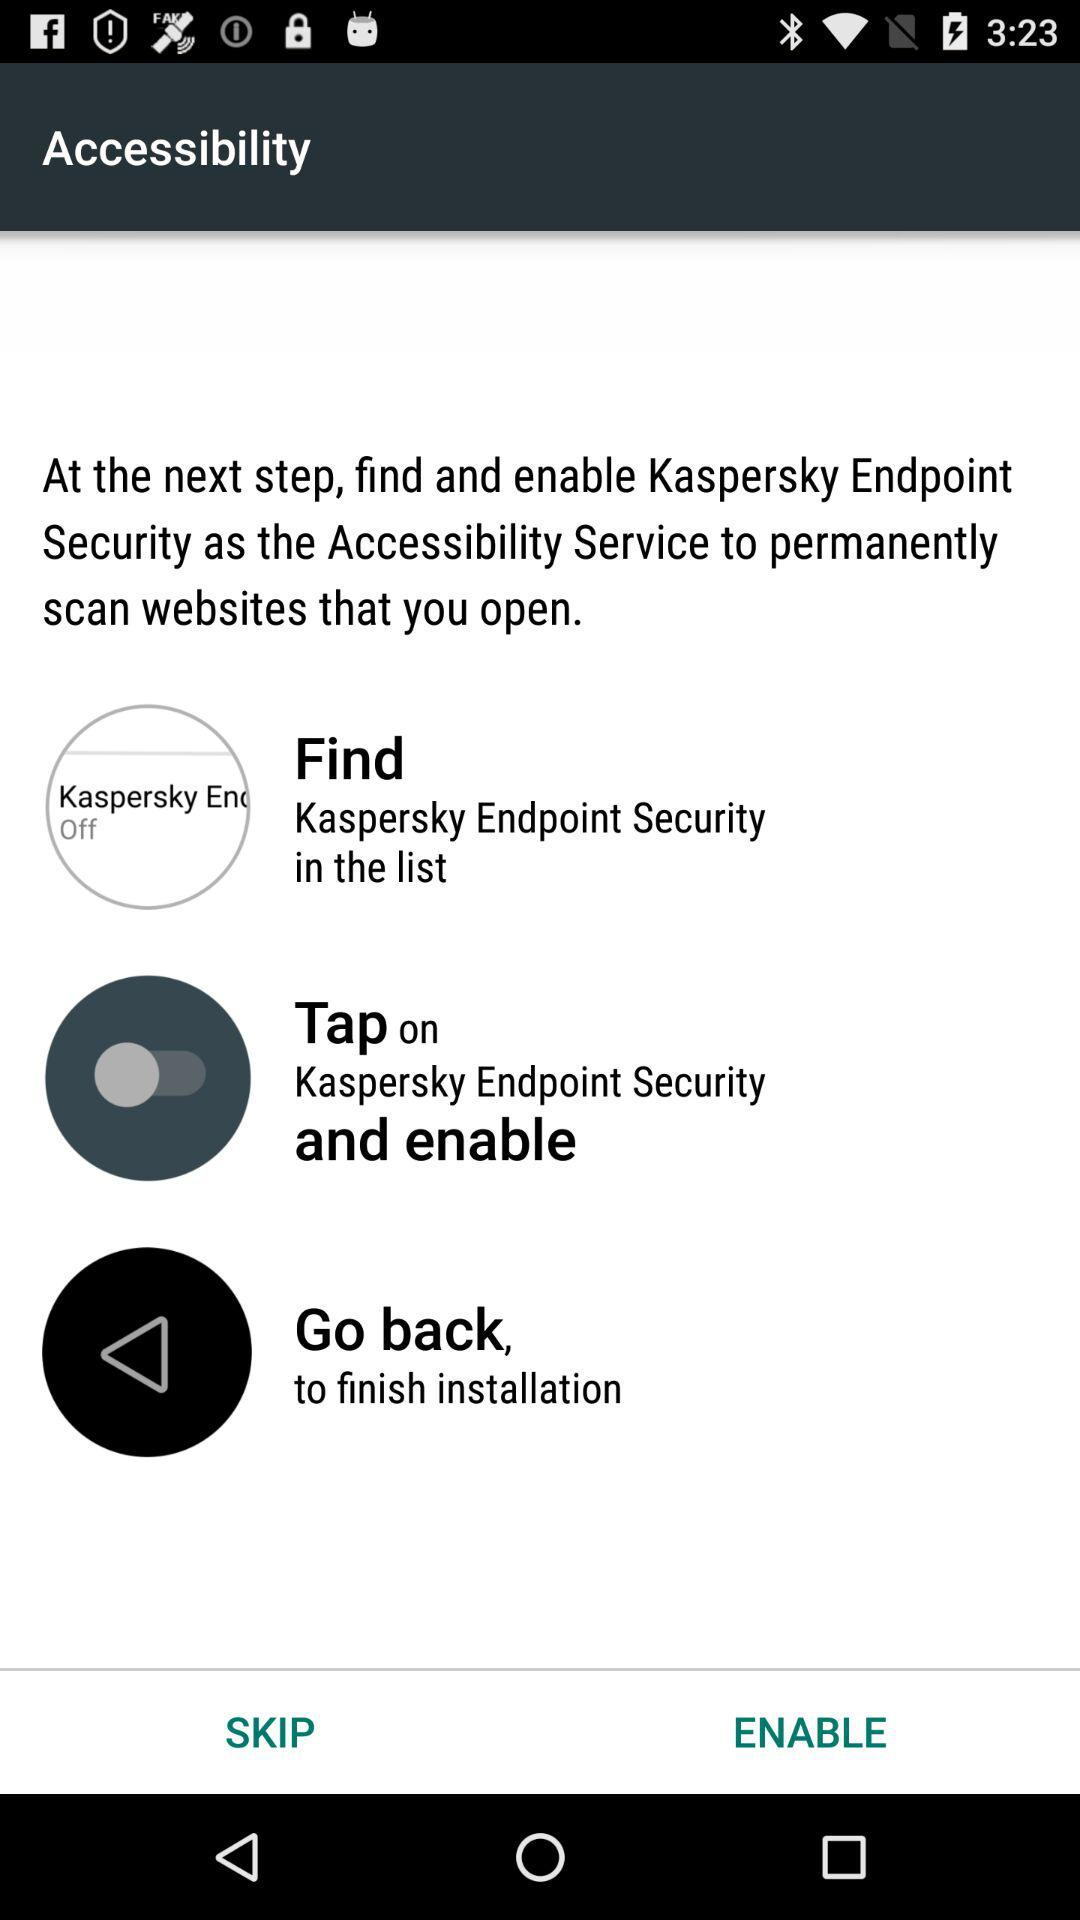How many steps are required to complete the installation?
Answer the question using a single word or phrase. 3 